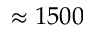<formula> <loc_0><loc_0><loc_500><loc_500>\approx 1 5 0 0</formula> 